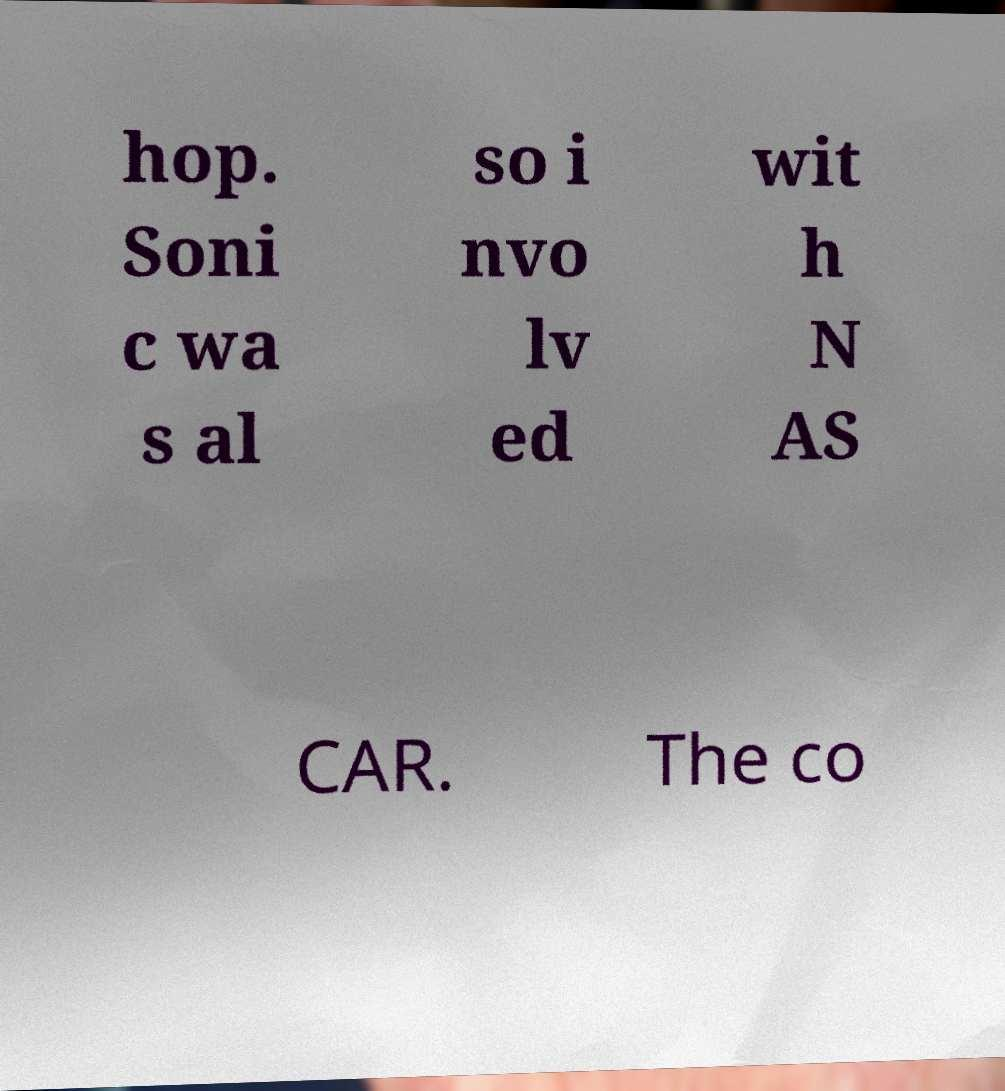Could you assist in decoding the text presented in this image and type it out clearly? hop. Soni c wa s al so i nvo lv ed wit h N AS CAR. The co 